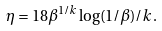<formula> <loc_0><loc_0><loc_500><loc_500>\eta = 1 8 \beta ^ { 1 / k } \log ( 1 / \beta ) / k .</formula> 